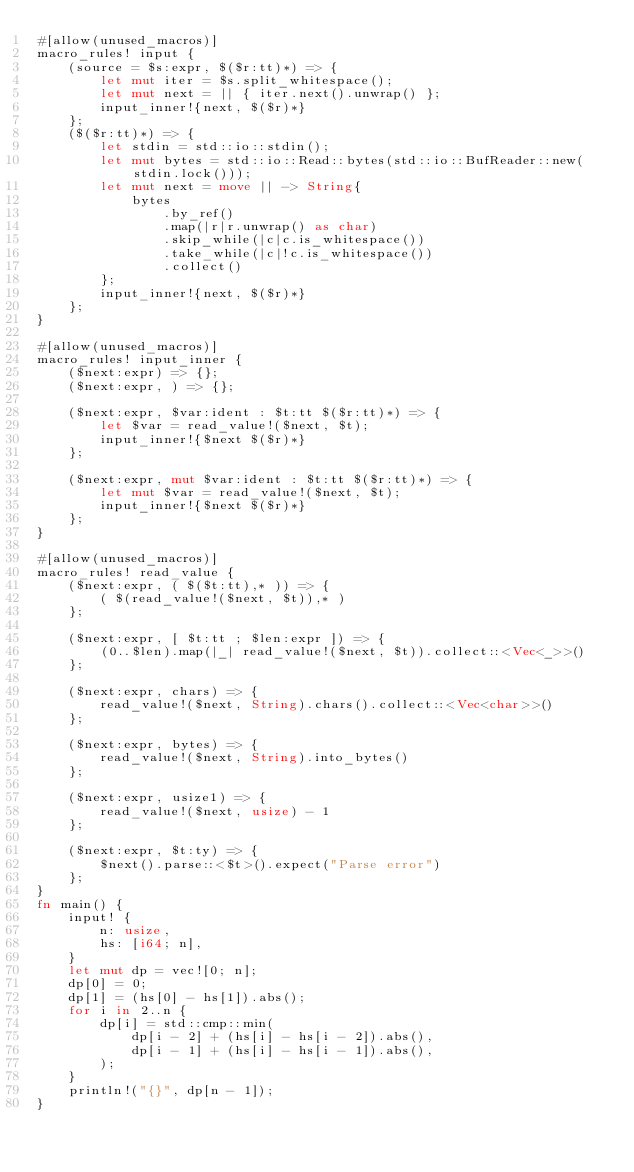Convert code to text. <code><loc_0><loc_0><loc_500><loc_500><_Rust_>#[allow(unused_macros)]
macro_rules! input {
    (source = $s:expr, $($r:tt)*) => {
        let mut iter = $s.split_whitespace();
        let mut next = || { iter.next().unwrap() };
        input_inner!{next, $($r)*}
    };
    ($($r:tt)*) => {
        let stdin = std::io::stdin();
        let mut bytes = std::io::Read::bytes(std::io::BufReader::new(stdin.lock()));
        let mut next = move || -> String{
            bytes
                .by_ref()
                .map(|r|r.unwrap() as char)
                .skip_while(|c|c.is_whitespace())
                .take_while(|c|!c.is_whitespace())
                .collect()
        };
        input_inner!{next, $($r)*}
    };
}

#[allow(unused_macros)]
macro_rules! input_inner {
    ($next:expr) => {};
    ($next:expr, ) => {};

    ($next:expr, $var:ident : $t:tt $($r:tt)*) => {
        let $var = read_value!($next, $t);
        input_inner!{$next $($r)*}
    };

    ($next:expr, mut $var:ident : $t:tt $($r:tt)*) => {
        let mut $var = read_value!($next, $t);
        input_inner!{$next $($r)*}
    };
}

#[allow(unused_macros)]
macro_rules! read_value {
    ($next:expr, ( $($t:tt),* )) => {
        ( $(read_value!($next, $t)),* )
    };

    ($next:expr, [ $t:tt ; $len:expr ]) => {
        (0..$len).map(|_| read_value!($next, $t)).collect::<Vec<_>>()
    };

    ($next:expr, chars) => {
        read_value!($next, String).chars().collect::<Vec<char>>()
    };

    ($next:expr, bytes) => {
        read_value!($next, String).into_bytes()
    };

    ($next:expr, usize1) => {
        read_value!($next, usize) - 1
    };

    ($next:expr, $t:ty) => {
        $next().parse::<$t>().expect("Parse error")
    };
}
fn main() {
    input! {
        n: usize,
        hs: [i64; n],
    }
    let mut dp = vec![0; n];
    dp[0] = 0;
    dp[1] = (hs[0] - hs[1]).abs();
    for i in 2..n {
        dp[i] = std::cmp::min(
            dp[i - 2] + (hs[i] - hs[i - 2]).abs(),
            dp[i - 1] + (hs[i] - hs[i - 1]).abs(),
        );
    }
    println!("{}", dp[n - 1]);
}
</code> 